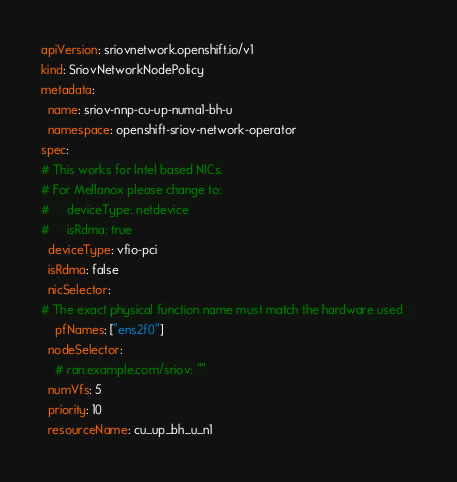Convert code to text. <code><loc_0><loc_0><loc_500><loc_500><_YAML_>apiVersion: sriovnetwork.openshift.io/v1
kind: SriovNetworkNodePolicy
metadata:
  name: sriov-nnp-cu-up-numa1-bh-u
  namespace: openshift-sriov-network-operator
spec:
# This works for Intel based NICs.
# For Mellanox please change to:
#     deviceType: netdevice
#     isRdma: true
  deviceType: vfio-pci
  isRdma: false
  nicSelector:
# The exact physical function name must match the hardware used    
    pfNames: ["ens2f0"]
  nodeSelector:
    # ran.example.com/sriov: ""
  numVfs: 5
  priority: 10
  resourceName: cu_up_bh_u_n1
</code> 